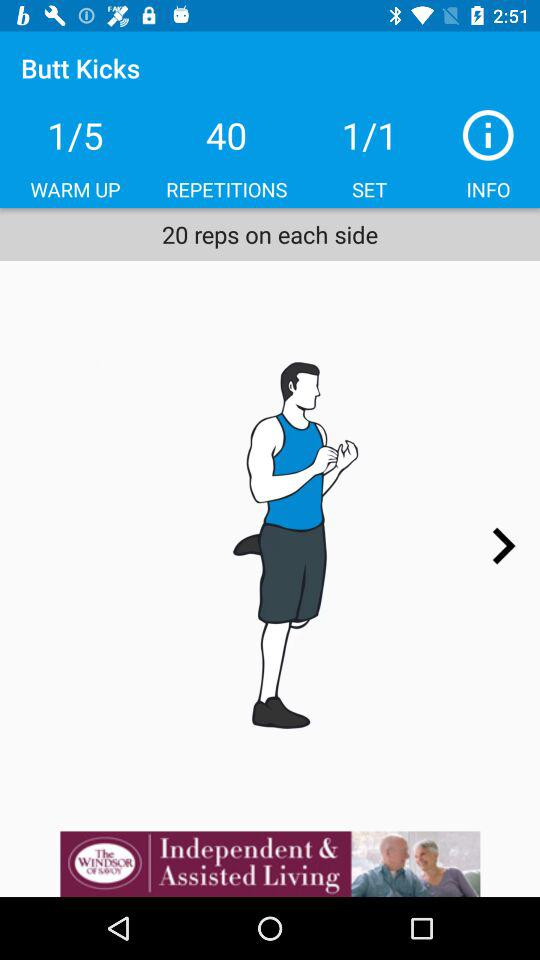How many reps of each side are there?
Answer the question using a single word or phrase. 20 